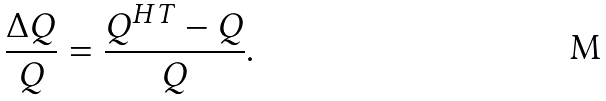Convert formula to latex. <formula><loc_0><loc_0><loc_500><loc_500>\frac { \Delta Q } { Q } = \frac { Q ^ { H T } - Q } { Q } .</formula> 